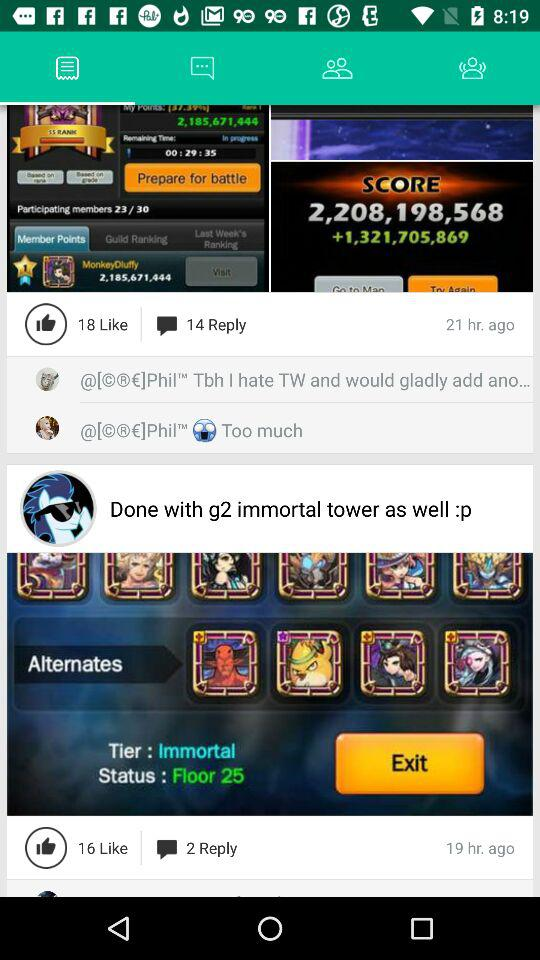How many replies are there on the "Done with g2 immortal tower as well"? There are 2 replies. 